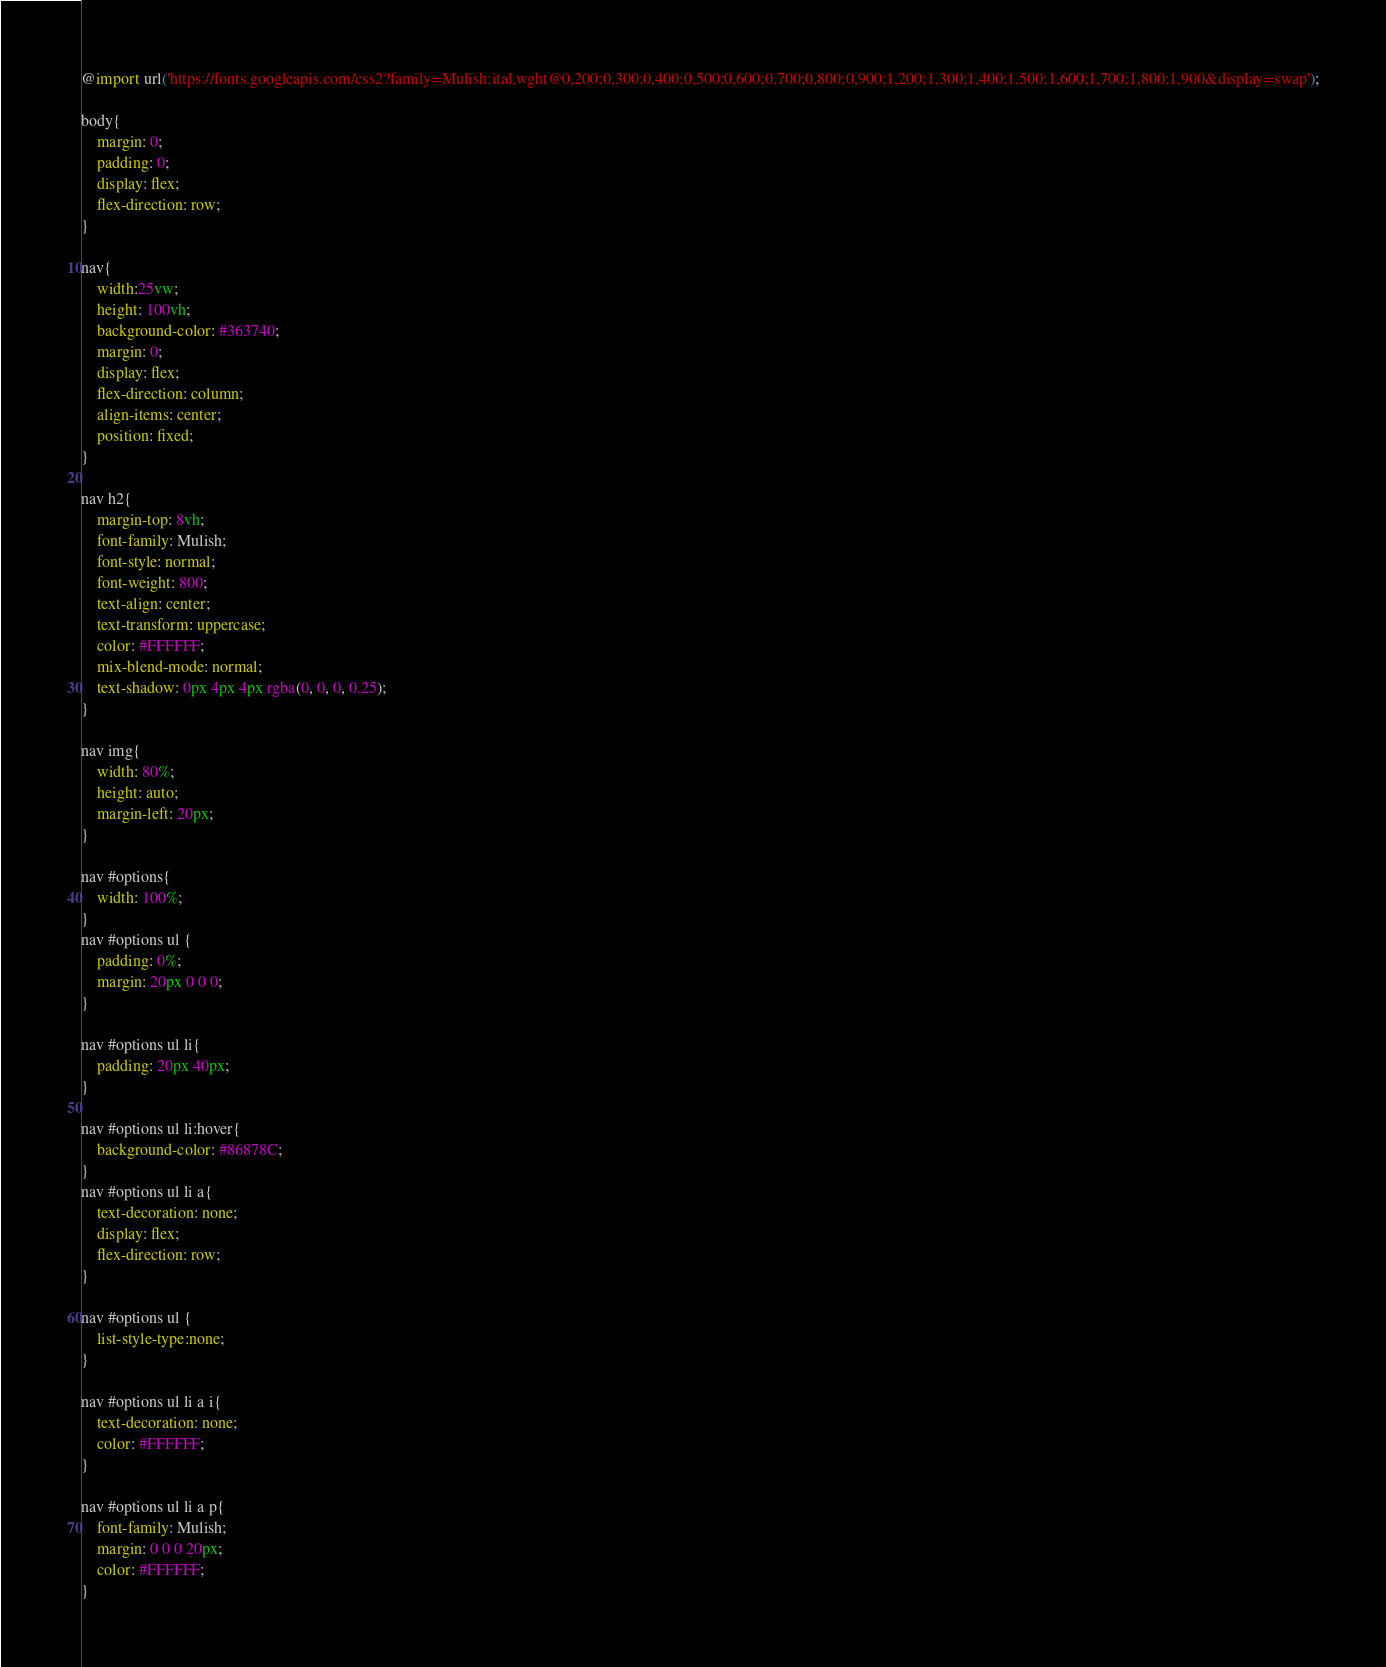<code> <loc_0><loc_0><loc_500><loc_500><_CSS_>@import url('https://fonts.googleapis.com/css2?family=Mulish:ital,wght@0,200;0,300;0,400;0,500;0,600;0,700;0,800;0,900;1,200;1,300;1,400;1,500;1,600;1,700;1,800;1,900&display=swap');

body{
    margin: 0;
    padding: 0;
    display: flex;
    flex-direction: row;
}

nav{
    width:25vw;
    height: 100vh;
    background-color: #363740;
    margin: 0;
    display: flex;
    flex-direction: column;
    align-items: center;
    position: fixed;
}

nav h2{
    margin-top: 8vh;
    font-family: Mulish;
    font-style: normal;
    font-weight: 800;
    text-align: center;
    text-transform: uppercase;
    color: #FFFFFF;
    mix-blend-mode: normal;
    text-shadow: 0px 4px 4px rgba(0, 0, 0, 0.25);
}

nav img{
    width: 80%;
    height: auto;
    margin-left: 20px;
}

nav #options{
    width: 100%;
}
nav #options ul {
    padding: 0%;
    margin: 20px 0 0 0;
}

nav #options ul li{
    padding: 20px 40px;
}

nav #options ul li:hover{
    background-color: #86878C;
}
nav #options ul li a{
    text-decoration: none;
    display: flex;
    flex-direction: row;
}

nav #options ul {
    list-style-type:none;
}

nav #options ul li a i{
    text-decoration: none;
    color: #FFFFFF;
}

nav #options ul li a p{
    font-family: Mulish;
    margin: 0 0 0 20px;
    color: #FFFFFF;
}
</code> 